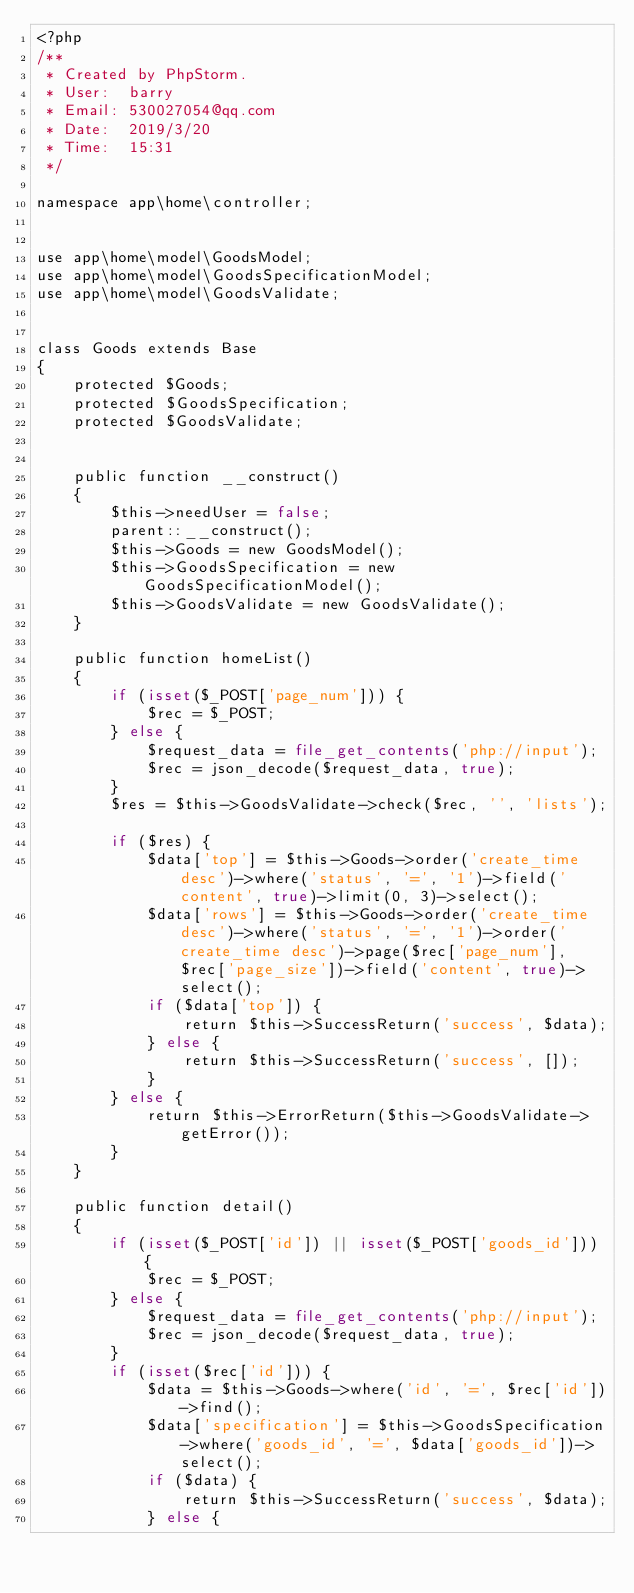<code> <loc_0><loc_0><loc_500><loc_500><_PHP_><?php
/**
 * Created by PhpStorm.
 * User:  barry
 * Email: 530027054@qq.com
 * Date:  2019/3/20
 * Time:  15:31
 */

namespace app\home\controller;


use app\home\model\GoodsModel;
use app\home\model\GoodsSpecificationModel;
use app\home\model\GoodsValidate;


class Goods extends Base
{
    protected $Goods;
    protected $GoodsSpecification;
    protected $GoodsValidate;


    public function __construct()
    {
        $this->needUser = false;
        parent::__construct();
        $this->Goods = new GoodsModel();
        $this->GoodsSpecification = new GoodsSpecificationModel();
        $this->GoodsValidate = new GoodsValidate();
    }

    public function homeList()
    {
        if (isset($_POST['page_num'])) {
            $rec = $_POST;
        } else {
            $request_data = file_get_contents('php://input');
            $rec = json_decode($request_data, true);
        }
        $res = $this->GoodsValidate->check($rec, '', 'lists');

        if ($res) {
            $data['top'] = $this->Goods->order('create_time desc')->where('status', '=', '1')->field('content', true)->limit(0, 3)->select();
            $data['rows'] = $this->Goods->order('create_time desc')->where('status', '=', '1')->order('create_time desc')->page($rec['page_num'], $rec['page_size'])->field('content', true)->select();
            if ($data['top']) {
                return $this->SuccessReturn('success', $data);
            } else {
                return $this->SuccessReturn('success', []);
            }
        } else {
            return $this->ErrorReturn($this->GoodsValidate->getError());
        }
    }

    public function detail()
    {
        if (isset($_POST['id']) || isset($_POST['goods_id'])) {
            $rec = $_POST;
        } else {
            $request_data = file_get_contents('php://input');
            $rec = json_decode($request_data, true);
        }
        if (isset($rec['id'])) {
            $data = $this->Goods->where('id', '=', $rec['id'])->find();
            $data['specification'] = $this->GoodsSpecification->where('goods_id', '=', $data['goods_id'])->select();
            if ($data) {
                return $this->SuccessReturn('success', $data);
            } else {</code> 